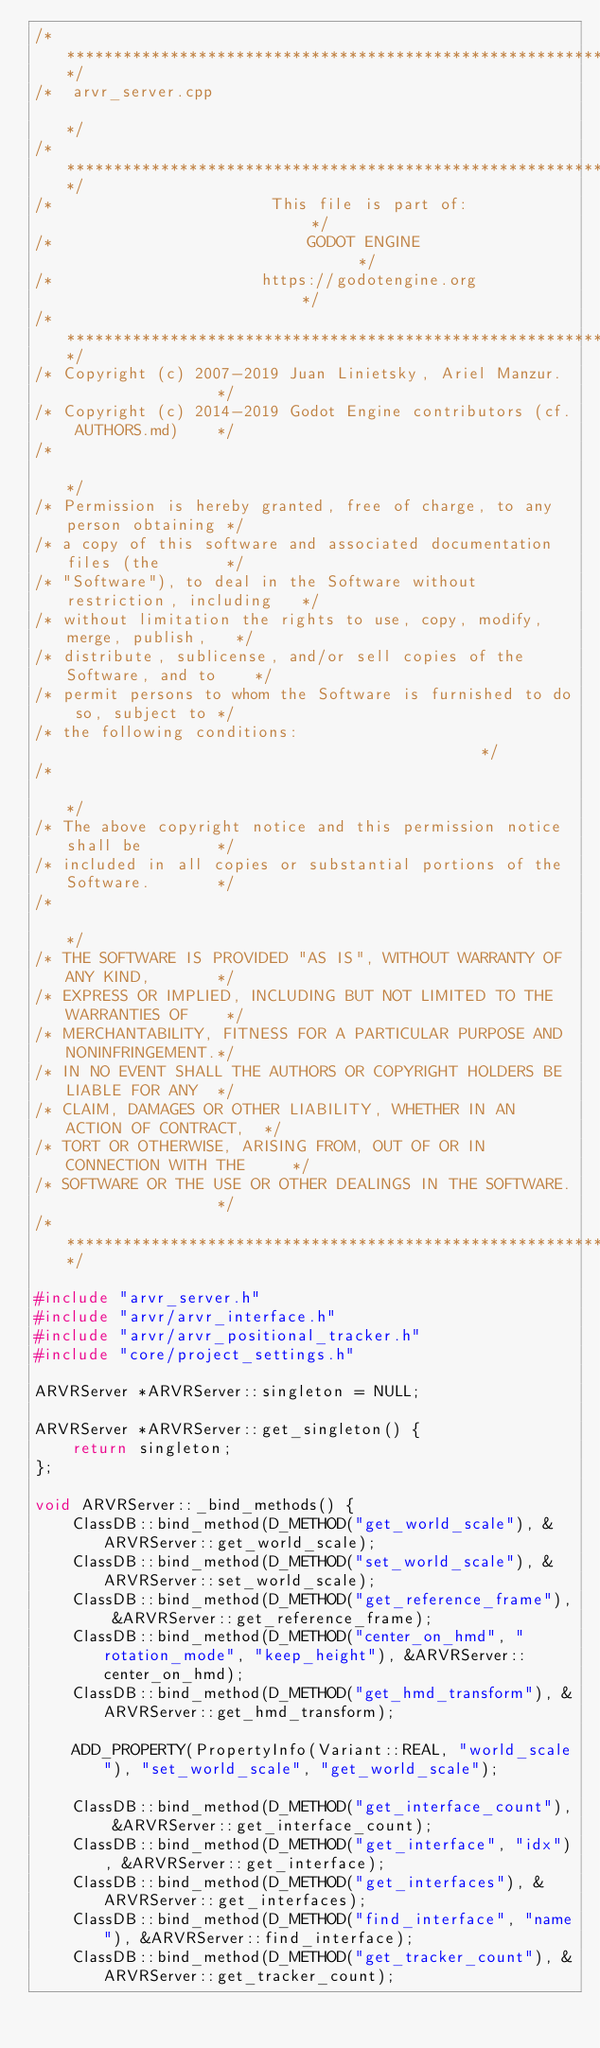<code> <loc_0><loc_0><loc_500><loc_500><_C++_>/*************************************************************************/
/*  arvr_server.cpp                                                      */
/*************************************************************************/
/*                       This file is part of:                           */
/*                           GODOT ENGINE                                */
/*                      https://godotengine.org                          */
/*************************************************************************/
/* Copyright (c) 2007-2019 Juan Linietsky, Ariel Manzur.                 */
/* Copyright (c) 2014-2019 Godot Engine contributors (cf. AUTHORS.md)    */
/*                                                                       */
/* Permission is hereby granted, free of charge, to any person obtaining */
/* a copy of this software and associated documentation files (the       */
/* "Software"), to deal in the Software without restriction, including   */
/* without limitation the rights to use, copy, modify, merge, publish,   */
/* distribute, sublicense, and/or sell copies of the Software, and to    */
/* permit persons to whom the Software is furnished to do so, subject to */
/* the following conditions:                                             */
/*                                                                       */
/* The above copyright notice and this permission notice shall be        */
/* included in all copies or substantial portions of the Software.       */
/*                                                                       */
/* THE SOFTWARE IS PROVIDED "AS IS", WITHOUT WARRANTY OF ANY KIND,       */
/* EXPRESS OR IMPLIED, INCLUDING BUT NOT LIMITED TO THE WARRANTIES OF    */
/* MERCHANTABILITY, FITNESS FOR A PARTICULAR PURPOSE AND NONINFRINGEMENT.*/
/* IN NO EVENT SHALL THE AUTHORS OR COPYRIGHT HOLDERS BE LIABLE FOR ANY  */
/* CLAIM, DAMAGES OR OTHER LIABILITY, WHETHER IN AN ACTION OF CONTRACT,  */
/* TORT OR OTHERWISE, ARISING FROM, OUT OF OR IN CONNECTION WITH THE     */
/* SOFTWARE OR THE USE OR OTHER DEALINGS IN THE SOFTWARE.                */
/*************************************************************************/

#include "arvr_server.h"
#include "arvr/arvr_interface.h"
#include "arvr/arvr_positional_tracker.h"
#include "core/project_settings.h"

ARVRServer *ARVRServer::singleton = NULL;

ARVRServer *ARVRServer::get_singleton() {
	return singleton;
};

void ARVRServer::_bind_methods() {
	ClassDB::bind_method(D_METHOD("get_world_scale"), &ARVRServer::get_world_scale);
	ClassDB::bind_method(D_METHOD("set_world_scale"), &ARVRServer::set_world_scale);
	ClassDB::bind_method(D_METHOD("get_reference_frame"), &ARVRServer::get_reference_frame);
	ClassDB::bind_method(D_METHOD("center_on_hmd", "rotation_mode", "keep_height"), &ARVRServer::center_on_hmd);
	ClassDB::bind_method(D_METHOD("get_hmd_transform"), &ARVRServer::get_hmd_transform);

	ADD_PROPERTY(PropertyInfo(Variant::REAL, "world_scale"), "set_world_scale", "get_world_scale");

	ClassDB::bind_method(D_METHOD("get_interface_count"), &ARVRServer::get_interface_count);
	ClassDB::bind_method(D_METHOD("get_interface", "idx"), &ARVRServer::get_interface);
	ClassDB::bind_method(D_METHOD("get_interfaces"), &ARVRServer::get_interfaces);
	ClassDB::bind_method(D_METHOD("find_interface", "name"), &ARVRServer::find_interface);
	ClassDB::bind_method(D_METHOD("get_tracker_count"), &ARVRServer::get_tracker_count);</code> 